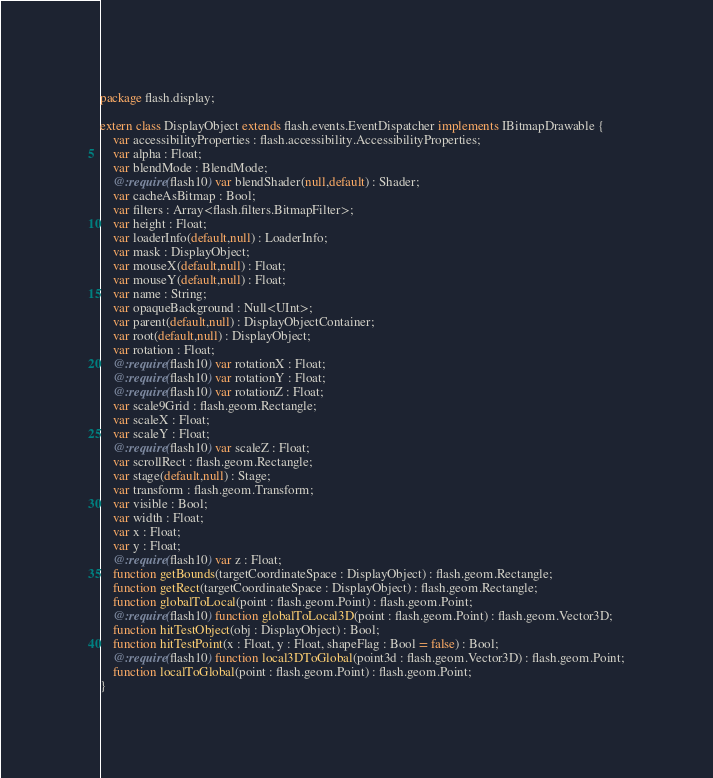<code> <loc_0><loc_0><loc_500><loc_500><_Haxe_>package flash.display;

extern class DisplayObject extends flash.events.EventDispatcher implements IBitmapDrawable {
	var accessibilityProperties : flash.accessibility.AccessibilityProperties;
	var alpha : Float;
	var blendMode : BlendMode;
	@:require(flash10) var blendShader(null,default) : Shader;
	var cacheAsBitmap : Bool;
	var filters : Array<flash.filters.BitmapFilter>;
	var height : Float;
	var loaderInfo(default,null) : LoaderInfo;
	var mask : DisplayObject;
	var mouseX(default,null) : Float;
	var mouseY(default,null) : Float;
	var name : String;
	var opaqueBackground : Null<UInt>;
	var parent(default,null) : DisplayObjectContainer;
	var root(default,null) : DisplayObject;
	var rotation : Float;
	@:require(flash10) var rotationX : Float;
	@:require(flash10) var rotationY : Float;
	@:require(flash10) var rotationZ : Float;
	var scale9Grid : flash.geom.Rectangle;
	var scaleX : Float;
	var scaleY : Float;
	@:require(flash10) var scaleZ : Float;
	var scrollRect : flash.geom.Rectangle;
	var stage(default,null) : Stage;
	var transform : flash.geom.Transform;
	var visible : Bool;
	var width : Float;
	var x : Float;
	var y : Float;
	@:require(flash10) var z : Float;
	function getBounds(targetCoordinateSpace : DisplayObject) : flash.geom.Rectangle;
	function getRect(targetCoordinateSpace : DisplayObject) : flash.geom.Rectangle;
	function globalToLocal(point : flash.geom.Point) : flash.geom.Point;
	@:require(flash10) function globalToLocal3D(point : flash.geom.Point) : flash.geom.Vector3D;
	function hitTestObject(obj : DisplayObject) : Bool;
	function hitTestPoint(x : Float, y : Float, shapeFlag : Bool = false) : Bool;
	@:require(flash10) function local3DToGlobal(point3d : flash.geom.Vector3D) : flash.geom.Point;
	function localToGlobal(point : flash.geom.Point) : flash.geom.Point;
}
</code> 